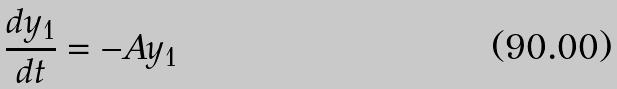Convert formula to latex. <formula><loc_0><loc_0><loc_500><loc_500>\frac { d y _ { 1 } } { d t } = - A y _ { 1 }</formula> 